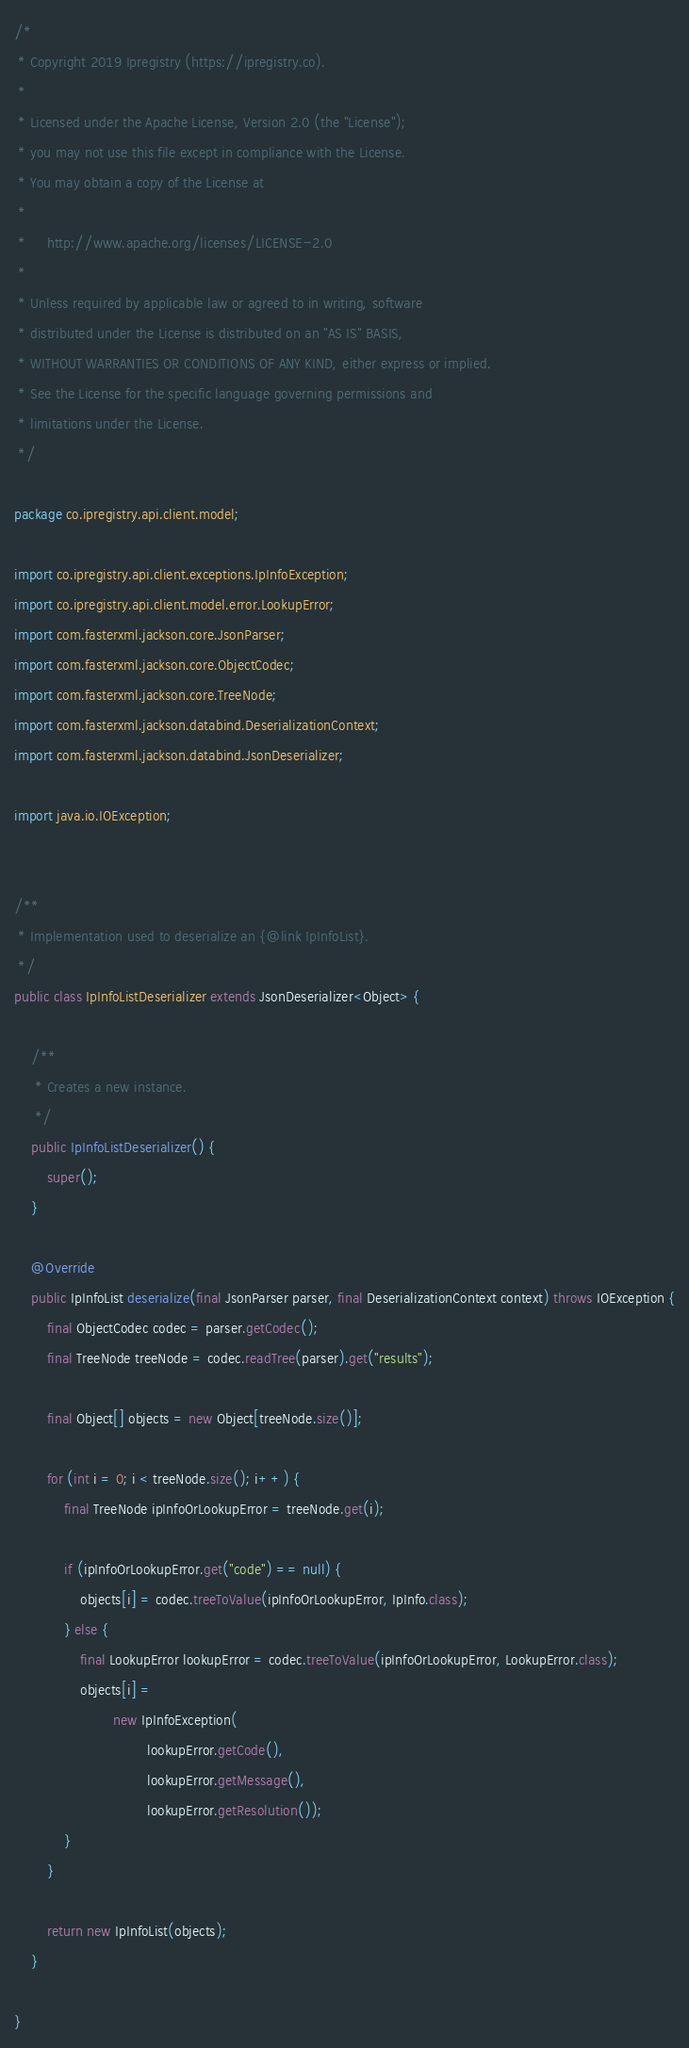<code> <loc_0><loc_0><loc_500><loc_500><_Java_>/*
 * Copyright 2019 Ipregistry (https://ipregistry.co).
 *
 * Licensed under the Apache License, Version 2.0 (the "License");
 * you may not use this file except in compliance with the License.
 * You may obtain a copy of the License at
 *
 *     http://www.apache.org/licenses/LICENSE-2.0
 *
 * Unless required by applicable law or agreed to in writing, software
 * distributed under the License is distributed on an "AS IS" BASIS,
 * WITHOUT WARRANTIES OR CONDITIONS OF ANY KIND, either express or implied.
 * See the License for the specific language governing permissions and
 * limitations under the License.
 */

package co.ipregistry.api.client.model;

import co.ipregistry.api.client.exceptions.IpInfoException;
import co.ipregistry.api.client.model.error.LookupError;
import com.fasterxml.jackson.core.JsonParser;
import com.fasterxml.jackson.core.ObjectCodec;
import com.fasterxml.jackson.core.TreeNode;
import com.fasterxml.jackson.databind.DeserializationContext;
import com.fasterxml.jackson.databind.JsonDeserializer;

import java.io.IOException;


/**
 * Implementation used to deserialize an {@link IpInfoList}.
 */
public class IpInfoListDeserializer extends JsonDeserializer<Object> {

    /**
     * Creates a new instance.
     */
    public IpInfoListDeserializer() {
        super();
    }

    @Override
    public IpInfoList deserialize(final JsonParser parser, final DeserializationContext context) throws IOException {
        final ObjectCodec codec = parser.getCodec();
        final TreeNode treeNode = codec.readTree(parser).get("results");

        final Object[] objects = new Object[treeNode.size()];

        for (int i = 0; i < treeNode.size(); i++) {
            final TreeNode ipInfoOrLookupError = treeNode.get(i);

            if (ipInfoOrLookupError.get("code") == null) {
                objects[i] = codec.treeToValue(ipInfoOrLookupError, IpInfo.class);
            } else {
                final LookupError lookupError = codec.treeToValue(ipInfoOrLookupError, LookupError.class);
                objects[i] =
                        new IpInfoException(
                                lookupError.getCode(),
                                lookupError.getMessage(),
                                lookupError.getResolution());
            }
        }

        return new IpInfoList(objects);
    }

}
</code> 